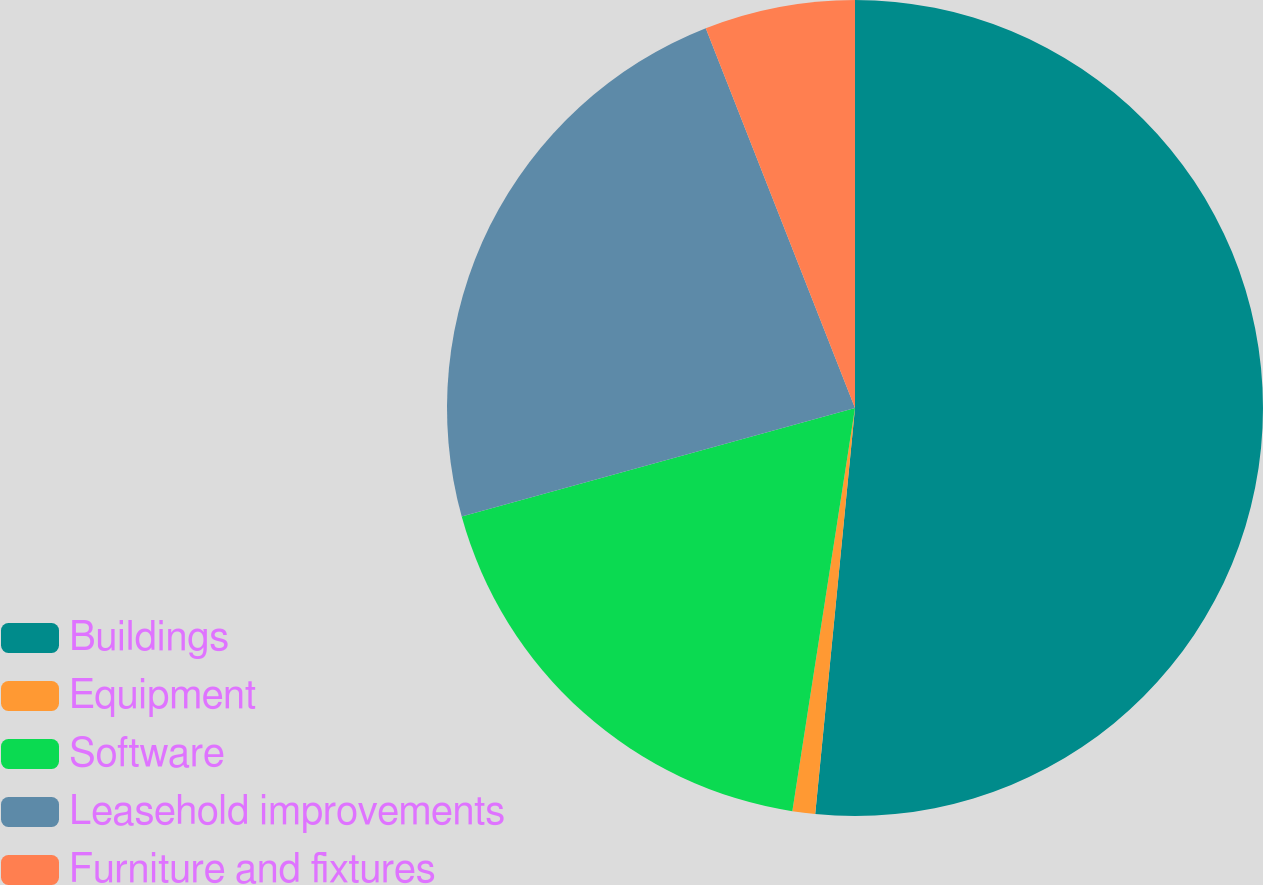Convert chart. <chart><loc_0><loc_0><loc_500><loc_500><pie_chart><fcel>Buildings<fcel>Equipment<fcel>Software<fcel>Leasehold improvements<fcel>Furniture and fixtures<nl><fcel>51.56%<fcel>0.9%<fcel>18.26%<fcel>23.33%<fcel>5.96%<nl></chart> 